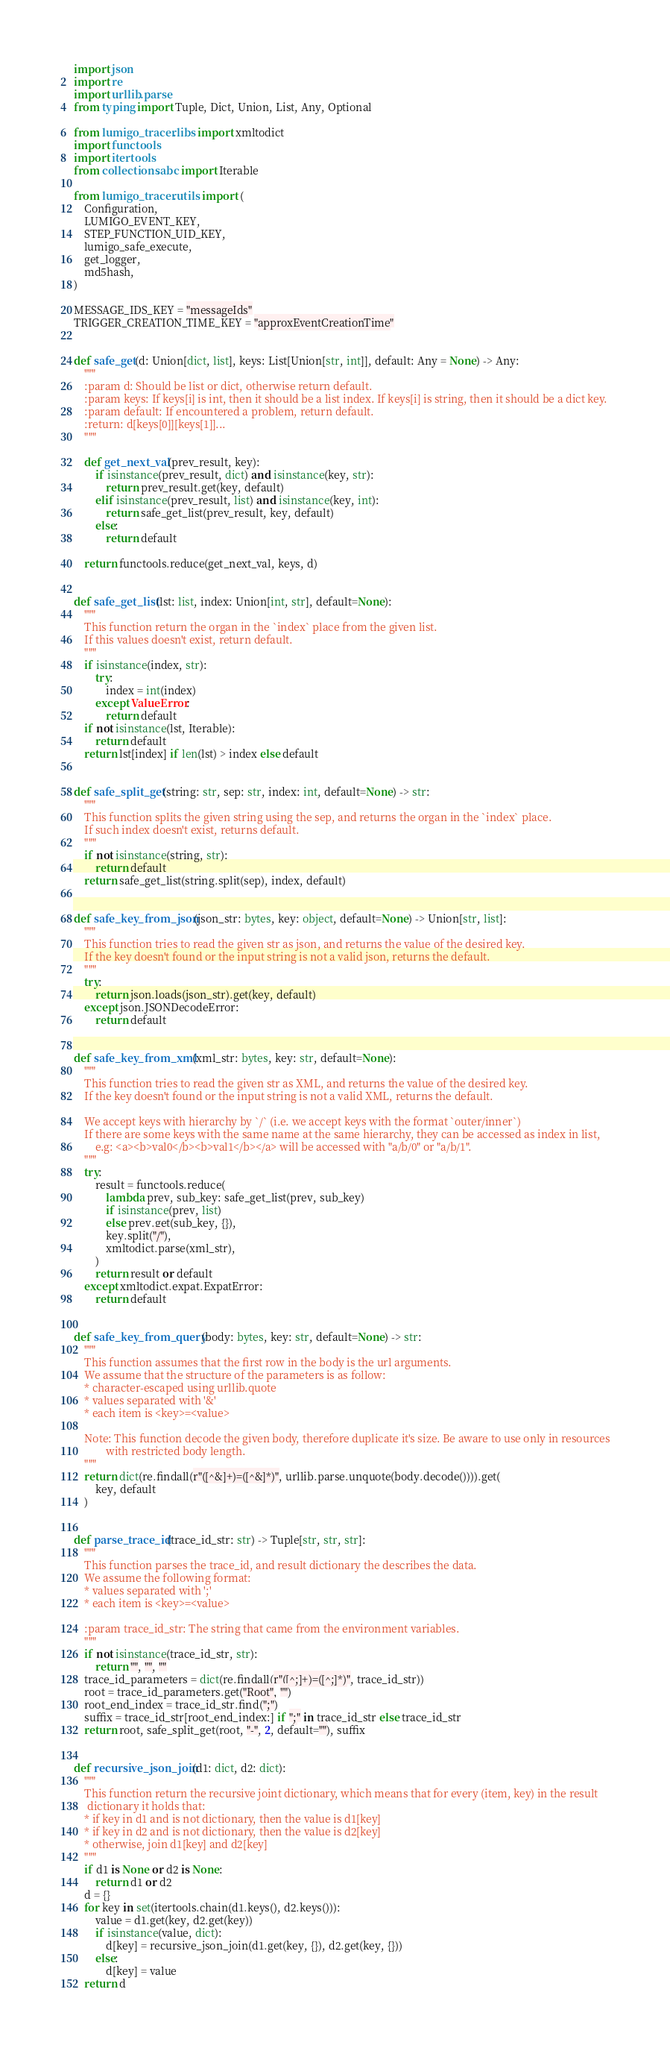<code> <loc_0><loc_0><loc_500><loc_500><_Python_>import json
import re
import urllib.parse
from typing import Tuple, Dict, Union, List, Any, Optional

from lumigo_tracer.libs import xmltodict
import functools
import itertools
from collections.abc import Iterable

from lumigo_tracer.utils import (
    Configuration,
    LUMIGO_EVENT_KEY,
    STEP_FUNCTION_UID_KEY,
    lumigo_safe_execute,
    get_logger,
    md5hash,
)

MESSAGE_IDS_KEY = "messageIds"
TRIGGER_CREATION_TIME_KEY = "approxEventCreationTime"


def safe_get(d: Union[dict, list], keys: List[Union[str, int]], default: Any = None) -> Any:
    """
    :param d: Should be list or dict, otherwise return default.
    :param keys: If keys[i] is int, then it should be a list index. If keys[i] is string, then it should be a dict key.
    :param default: If encountered a problem, return default.
    :return: d[keys[0]][keys[1]]...
    """

    def get_next_val(prev_result, key):
        if isinstance(prev_result, dict) and isinstance(key, str):
            return prev_result.get(key, default)
        elif isinstance(prev_result, list) and isinstance(key, int):
            return safe_get_list(prev_result, key, default)
        else:
            return default

    return functools.reduce(get_next_val, keys, d)


def safe_get_list(lst: list, index: Union[int, str], default=None):
    """
    This function return the organ in the `index` place from the given list.
    If this values doesn't exist, return default.
    """
    if isinstance(index, str):
        try:
            index = int(index)
        except ValueError:
            return default
    if not isinstance(lst, Iterable):
        return default
    return lst[index] if len(lst) > index else default


def safe_split_get(string: str, sep: str, index: int, default=None) -> str:
    """
    This function splits the given string using the sep, and returns the organ in the `index` place.
    If such index doesn't exist, returns default.
    """
    if not isinstance(string, str):
        return default
    return safe_get_list(string.split(sep), index, default)


def safe_key_from_json(json_str: bytes, key: object, default=None) -> Union[str, list]:
    """
    This function tries to read the given str as json, and returns the value of the desired key.
    If the key doesn't found or the input string is not a valid json, returns the default.
    """
    try:
        return json.loads(json_str).get(key, default)
    except json.JSONDecodeError:
        return default


def safe_key_from_xml(xml_str: bytes, key: str, default=None):
    """
    This function tries to read the given str as XML, and returns the value of the desired key.
    If the key doesn't found or the input string is not a valid XML, returns the default.

    We accept keys with hierarchy by `/` (i.e. we accept keys with the format `outer/inner`)
    If there are some keys with the same name at the same hierarchy, they can be accessed as index in list,
        e.g: <a><b>val0</b><b>val1</b></a> will be accessed with "a/b/0" or "a/b/1".
    """
    try:
        result = functools.reduce(
            lambda prev, sub_key: safe_get_list(prev, sub_key)
            if isinstance(prev, list)
            else prev.get(sub_key, {}),
            key.split("/"),
            xmltodict.parse(xml_str),
        )
        return result or default
    except xmltodict.expat.ExpatError:
        return default


def safe_key_from_query(body: bytes, key: str, default=None) -> str:
    """
    This function assumes that the first row in the body is the url arguments.
    We assume that the structure of the parameters is as follow:
    * character-escaped using urllib.quote
    * values separated with '&'
    * each item is <key>=<value>

    Note: This function decode the given body, therefore duplicate it's size. Be aware to use only in resources
            with restricted body length.
    """
    return dict(re.findall(r"([^&]+)=([^&]*)", urllib.parse.unquote(body.decode()))).get(
        key, default
    )


def parse_trace_id(trace_id_str: str) -> Tuple[str, str, str]:
    """
    This function parses the trace_id, and result dictionary the describes the data.
    We assume the following format:
    * values separated with ';'
    * each item is <key>=<value>

    :param trace_id_str: The string that came from the environment variables.
    """
    if not isinstance(trace_id_str, str):
        return "", "", ""
    trace_id_parameters = dict(re.findall(r"([^;]+)=([^;]*)", trace_id_str))
    root = trace_id_parameters.get("Root", "")
    root_end_index = trace_id_str.find(";")
    suffix = trace_id_str[root_end_index:] if ";" in trace_id_str else trace_id_str
    return root, safe_split_get(root, "-", 2, default=""), suffix


def recursive_json_join(d1: dict, d2: dict):
    """
    This function return the recursive joint dictionary, which means that for every (item, key) in the result
     dictionary it holds that:
    * if key in d1 and is not dictionary, then the value is d1[key]
    * if key in d2 and is not dictionary, then the value is d2[key]
    * otherwise, join d1[key] and d2[key]
    """
    if d1 is None or d2 is None:
        return d1 or d2
    d = {}
    for key in set(itertools.chain(d1.keys(), d2.keys())):
        value = d1.get(key, d2.get(key))
        if isinstance(value, dict):
            d[key] = recursive_json_join(d1.get(key, {}), d2.get(key, {}))
        else:
            d[key] = value
    return d

</code> 